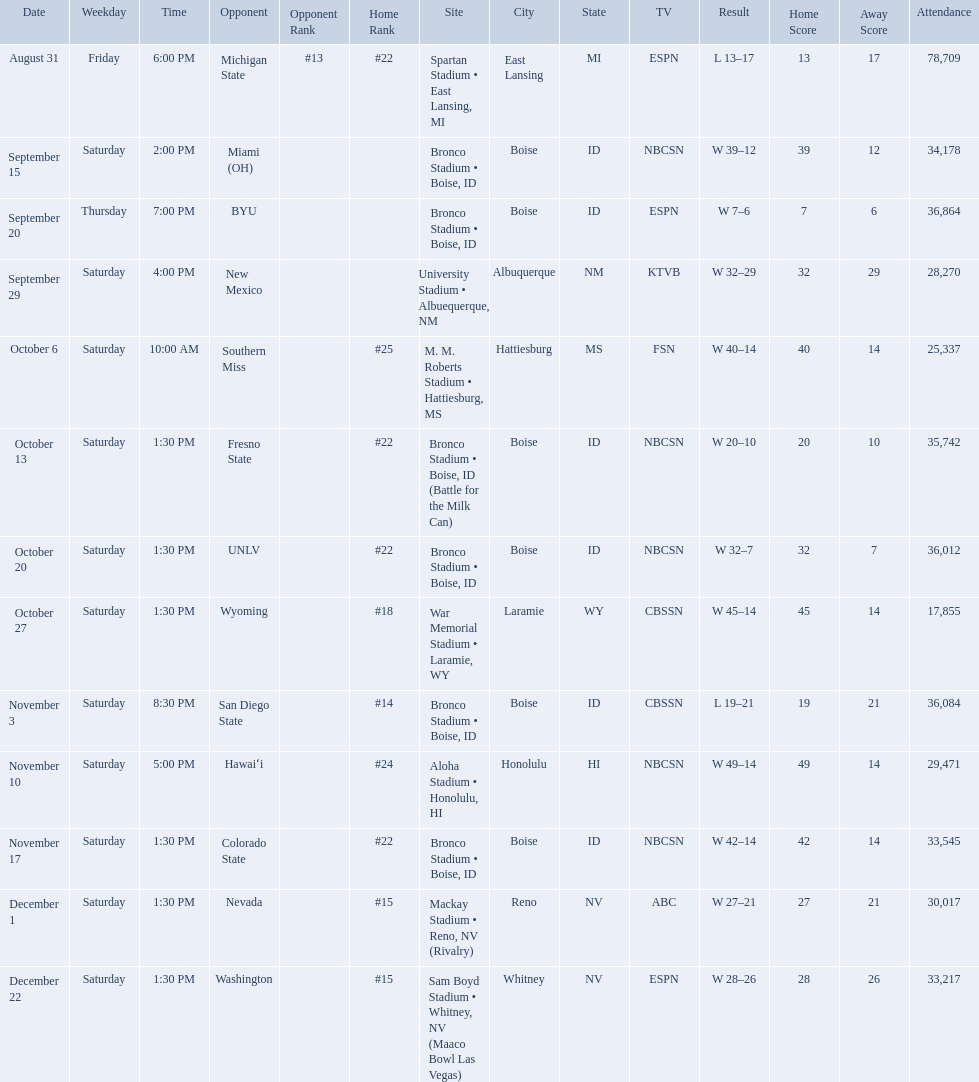What was the team's listed rankings for the season? #22, , , , #25, #22, #22, #18, #14, #24, #22, #15, #15. Which of these ranks is the best? #14. What are the opponents to the  2012 boise state broncos football team? At #13 michigan state*, miami (oh)*, byu*, at new mexico, at southern miss*, fresno state, unlv, at wyoming, san diego state, at hawaiʻi, colorado state, at nevada, vs. washington*. Which is the highest ranked of the teams? San Diego State. Who were all the opponents for boise state? At #13 michigan state*, miami (oh)*, byu*, at new mexico, at southern miss*, fresno state, unlv, at wyoming, san diego state, at hawaiʻi, colorado state, at nevada, vs. washington*. Parse the full table. {'header': ['Date', 'Weekday', 'Time', 'Opponent', 'Opponent Rank', 'Home Rank', 'Site', 'City', 'State', 'TV', 'Result', 'Home Score', 'Away Score', 'Attendance'], 'rows': [['August 31', 'Friday', '6:00 PM', 'Michigan State', '#13', '#22', 'Spartan Stadium • East Lansing, MI', 'East Lansing', 'MI', 'ESPN', 'L\xa013–17', '13', '17', '78,709'], ['September 15', 'Saturday', '2:00 PM', 'Miami (OH)', '', '', 'Bronco Stadium • Boise, ID', 'Boise', 'ID', 'NBCSN', 'W\xa039–12', '39', '12', '34,178'], ['September 20', 'Thursday', '7:00 PM', 'BYU', '', '', 'Bronco Stadium • Boise, ID', 'Boise', 'ID', 'ESPN', 'W\xa07–6', '7', '6', '36,864'], ['September 29', 'Saturday', '4:00 PM', 'New Mexico', '', '', 'University Stadium • Albuequerque, NM', 'Albuquerque', 'NM', 'KTVB', 'W\xa032–29', '32', '29', '28,270'], ['October 6', 'Saturday', '10:00 AM', 'Southern Miss', '', '#25', 'M. M. Roberts Stadium • Hattiesburg, MS', 'Hattiesburg', 'MS', 'FSN', 'W\xa040–14', '40', '14', '25,337'], ['October 13', 'Saturday', '1:30 PM', 'Fresno State', '', '#22', 'Bronco Stadium • Boise, ID (Battle for the Milk Can)', 'Boise', 'ID', 'NBCSN', 'W\xa020–10', '20', '10', '35,742'], ['October 20', 'Saturday', '1:30 PM', 'UNLV', '', '#22', 'Bronco Stadium • Boise, ID', 'Boise', 'ID', 'NBCSN', 'W\xa032–7', '32', '7', '36,012'], ['October 27', 'Saturday', '1:30 PM', 'Wyoming', '', '#18', 'War Memorial Stadium • Laramie, WY', 'Laramie', 'WY', 'CBSSN', 'W\xa045–14', '45', '14', '17,855'], ['November 3', 'Saturday', '8:30 PM', 'San Diego State', '', '#14', 'Bronco Stadium • Boise, ID', 'Boise', 'ID', 'CBSSN', 'L\xa019–21', '19', '21', '36,084'], ['November 10', 'Saturday', '5:00 PM', 'Hawaiʻi', '', '#24', 'Aloha Stadium • Honolulu, HI', 'Honolulu', 'HI', 'NBCSN', 'W\xa049–14', '49', '14', '29,471'], ['November 17', 'Saturday', '1:30 PM', 'Colorado State', '', '#22', 'Bronco Stadium • Boise, ID', 'Boise', 'ID', 'NBCSN', 'W\xa042–14', '42', '14', '33,545'], ['December 1', 'Saturday', '1:30 PM', 'Nevada', '', '#15', 'Mackay Stadium • Reno, NV (Rivalry)', 'Reno', 'NV', 'ABC', 'W\xa027–21', '27', '21', '30,017'], ['December 22', 'Saturday', '1:30 PM', 'Washington', '', '#15', 'Sam Boyd Stadium • Whitney, NV (Maaco Bowl Las Vegas)', 'Whitney', 'NV', 'ESPN', 'W\xa028–26', '28', '26', '33,217']]} Which opponents were ranked? At #13 michigan state*, #22, at southern miss*, #25, fresno state, #22, unlv, #22, at wyoming, #18, san diego state, #14. Which opponent had the highest rank? San Diego State. 